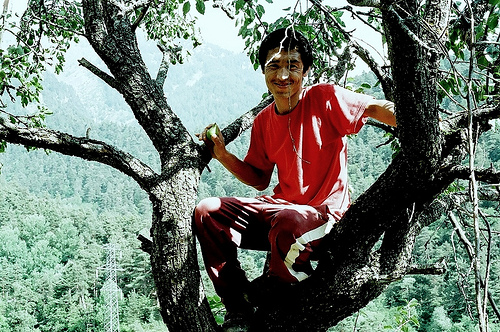<image>
Is there a man on the tree? Yes. Looking at the image, I can see the man is positioned on top of the tree, with the tree providing support. 